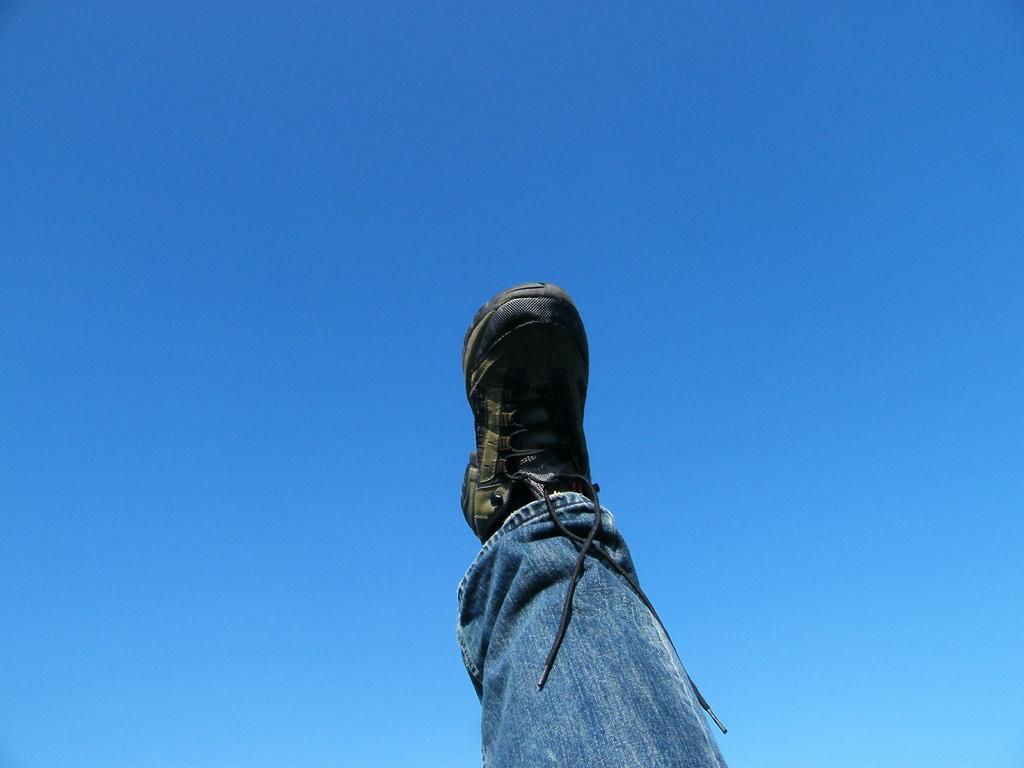Describe this image in one or two sentences. In this picture there is a leg of the person in the front which is visible and at the top there is sky which is blue in colour. 